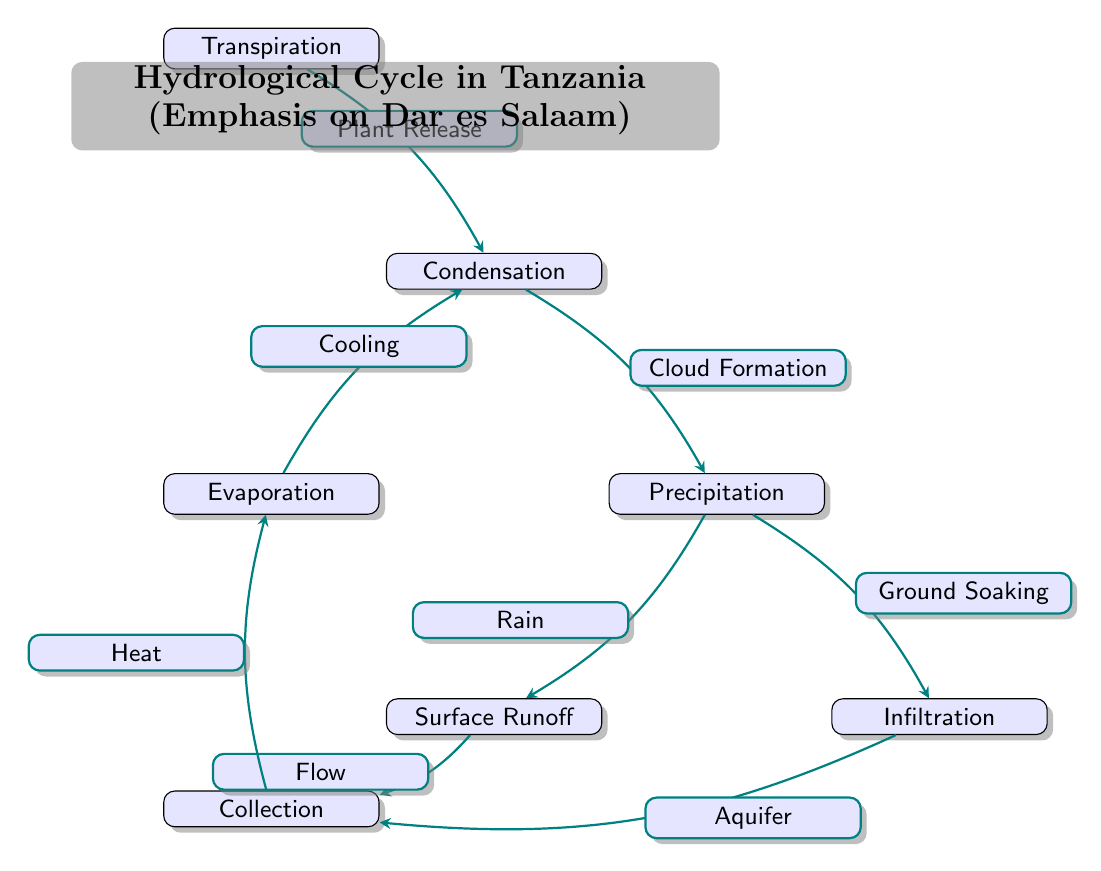What is the first step in the hydrological cycle? The diagram indicates that "Evaporation" is the first node in the hydrological cycle process. It is positioned at the top and is the starting point before cooling leads to condensation.
Answer: Evaporation What is the node that directly follows condensation? According to the diagram, "Precipitation" is directly connected to the "Condensation" node, indicating that condensation leads to precipitation in the hydrological cycle.
Answer: Precipitation How many key processes are included in the hydrological cycle diagram? By counting the nodes in the diagram, there are a total of 7 key processes: Evaporation, Condensation, Precipitation, Surface Runoff, Infiltration, Transpiration, and Collection.
Answer: Seven What process follows precipitation in the hydrological cycle for surface water? The diagram shows that after "Precipitation," the water can either lead to "Surface Runoff" or "Infiltration." The specific process that refers to the flowing away of water is "Surface Runoff."
Answer: Surface Runoff What does transpiration contribute to in the hydrological cycle? Transpiration is shown to lead to "Condensation" in the diagram, indicating that water released by plants contributes to cloud formation in the cycle.
Answer: Condensation Which processes are considered collection stages in the hydrological cycle? The final node labeled "Collection" is the stage where water gathers after going through the cycle, indicated by arrows from both "Surface Runoff" and "Infiltration."
Answer: Surface Runoff and Infiltration What type of relationship is indicated from collection back to evaporation? The arrow from "Collection" to "Evaporation" is labeled with "Heat," suggesting that the collection stage provides heat which facilitates the evaporation process.
Answer: Heat How does infiltration contribute back to the system after precipitation? Infiltration redirects water into underground aquifers, which is represented in the diagram as leading back to the "Collection" node. This indicates that water stored underground can eventually re-enter the cycle.
Answer: Aquifer What effect does cooling have in the hydrological cycle? The diagram connects "Cooling" as the primary process that leads from "Evaporation" to "Condensation," emphasizing that cooling causes vapor to condense into droplets.
Answer: Condensation 